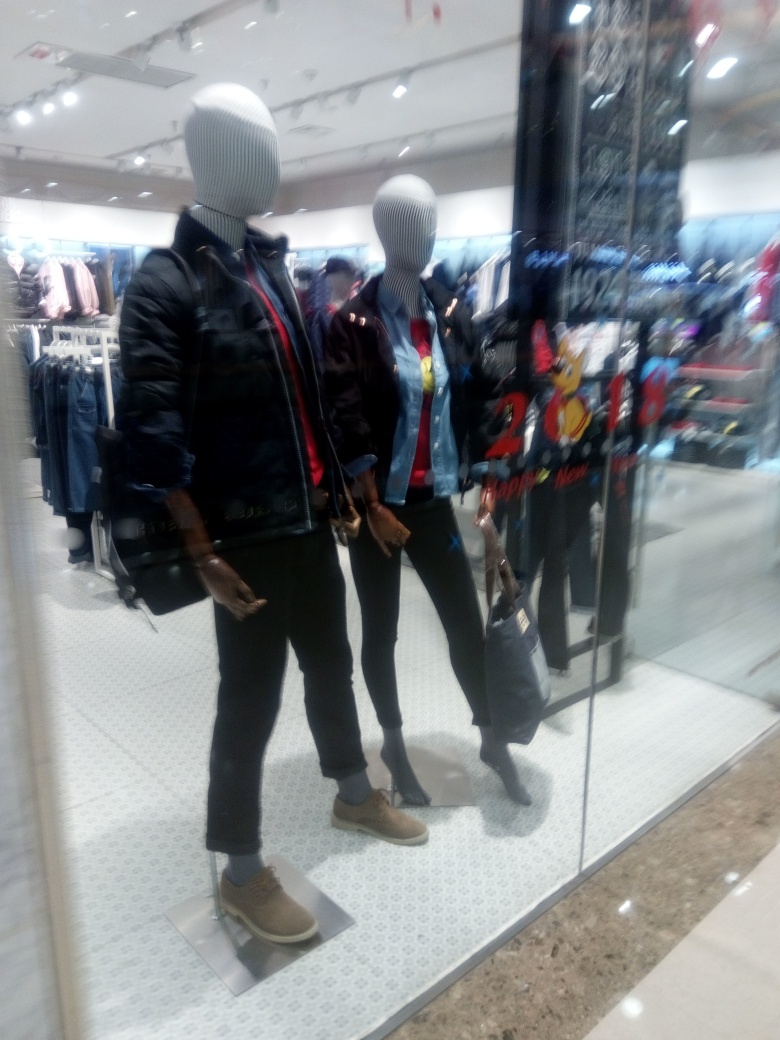What is the quality of this image? The image quality is suboptimal due to blurriness and lack of focus, as well as possible motion blur, which detracts from the clarity of the mannequins and the clothing they are displaying. Furthermore, the lighting conditions and reflections on the glass add to the difficulty in discerning fine details. 